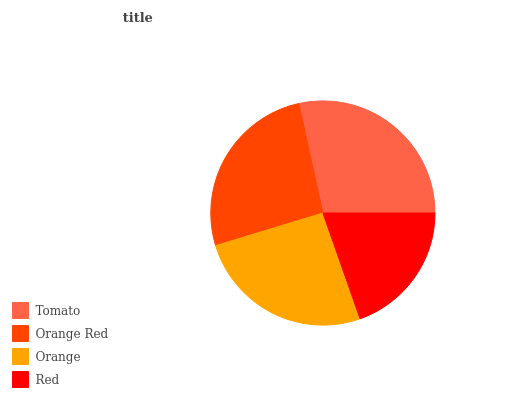Is Red the minimum?
Answer yes or no. Yes. Is Tomato the maximum?
Answer yes or no. Yes. Is Orange Red the minimum?
Answer yes or no. No. Is Orange Red the maximum?
Answer yes or no. No. Is Tomato greater than Orange Red?
Answer yes or no. Yes. Is Orange Red less than Tomato?
Answer yes or no. Yes. Is Orange Red greater than Tomato?
Answer yes or no. No. Is Tomato less than Orange Red?
Answer yes or no. No. Is Orange Red the high median?
Answer yes or no. Yes. Is Orange the low median?
Answer yes or no. Yes. Is Orange the high median?
Answer yes or no. No. Is Orange Red the low median?
Answer yes or no. No. 